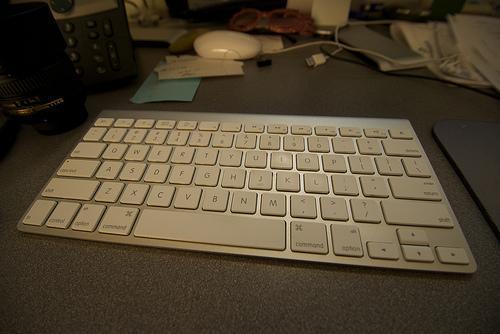How many mouses are in this picture?
Give a very brief answer. 1. 